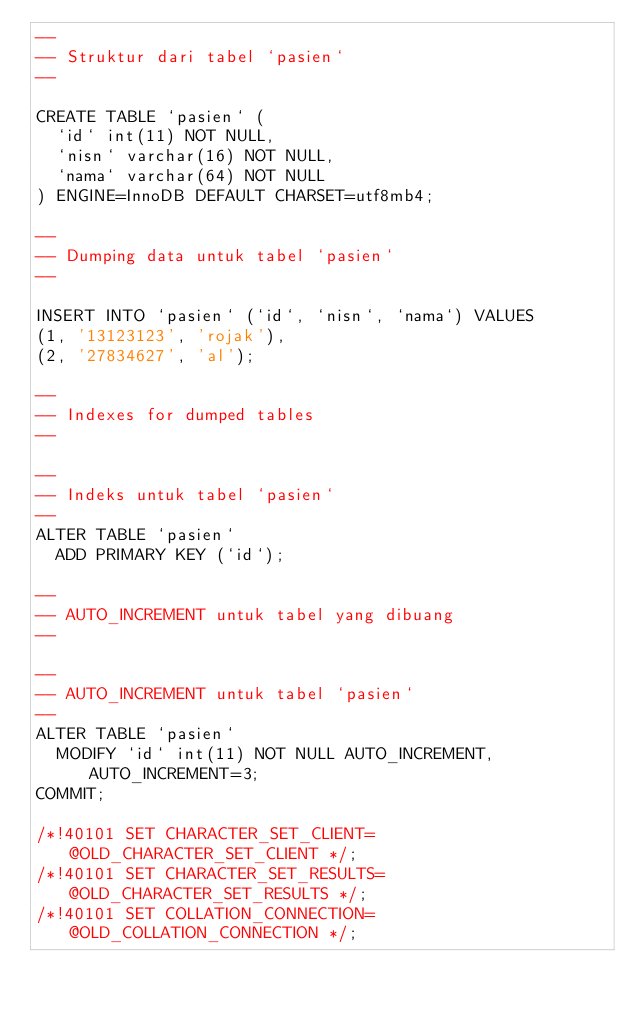Convert code to text. <code><loc_0><loc_0><loc_500><loc_500><_SQL_>--
-- Struktur dari tabel `pasien`
--

CREATE TABLE `pasien` (
  `id` int(11) NOT NULL,
  `nisn` varchar(16) NOT NULL,
  `nama` varchar(64) NOT NULL
) ENGINE=InnoDB DEFAULT CHARSET=utf8mb4;

--
-- Dumping data untuk tabel `pasien`
--

INSERT INTO `pasien` (`id`, `nisn`, `nama`) VALUES
(1, '13123123', 'rojak'),
(2, '27834627', 'al');

--
-- Indexes for dumped tables
--

--
-- Indeks untuk tabel `pasien`
--
ALTER TABLE `pasien`
  ADD PRIMARY KEY (`id`);

--
-- AUTO_INCREMENT untuk tabel yang dibuang
--

--
-- AUTO_INCREMENT untuk tabel `pasien`
--
ALTER TABLE `pasien`
  MODIFY `id` int(11) NOT NULL AUTO_INCREMENT, AUTO_INCREMENT=3;
COMMIT;

/*!40101 SET CHARACTER_SET_CLIENT=@OLD_CHARACTER_SET_CLIENT */;
/*!40101 SET CHARACTER_SET_RESULTS=@OLD_CHARACTER_SET_RESULTS */;
/*!40101 SET COLLATION_CONNECTION=@OLD_COLLATION_CONNECTION */;
</code> 